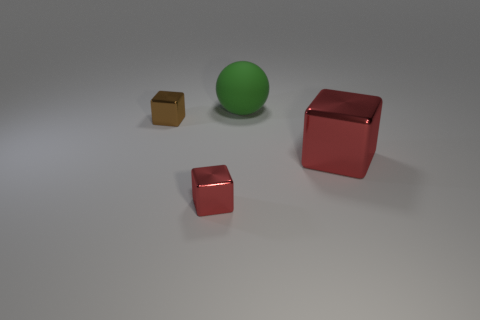Subtract all red blocks. How many blocks are left? 1 Subtract all brown blocks. How many blocks are left? 2 Add 3 large red metal objects. How many objects exist? 7 Subtract all cubes. How many objects are left? 1 Subtract 1 spheres. How many spheres are left? 0 Subtract 0 blue cylinders. How many objects are left? 4 Subtract all purple spheres. Subtract all red cylinders. How many spheres are left? 1 Subtract all yellow spheres. How many brown blocks are left? 1 Subtract all big cyan rubber objects. Subtract all big red cubes. How many objects are left? 3 Add 1 big red shiny things. How many big red shiny things are left? 2 